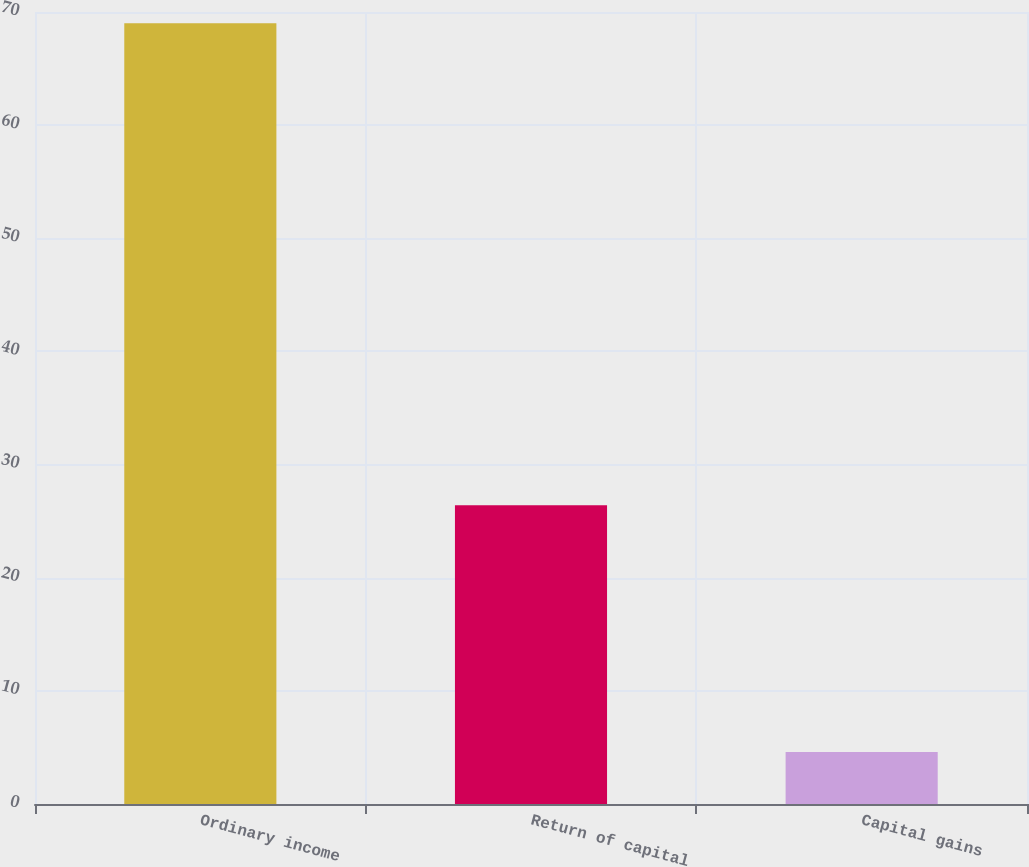Convert chart. <chart><loc_0><loc_0><loc_500><loc_500><bar_chart><fcel>Ordinary income<fcel>Return of capital<fcel>Capital gains<nl><fcel>69<fcel>26.4<fcel>4.6<nl></chart> 